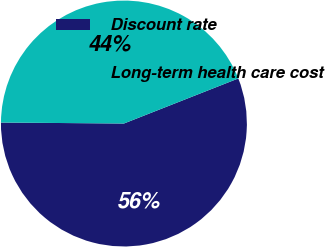Convert chart. <chart><loc_0><loc_0><loc_500><loc_500><pie_chart><fcel>Discount rate<fcel>Long-term health care cost<nl><fcel>56.1%<fcel>43.9%<nl></chart> 